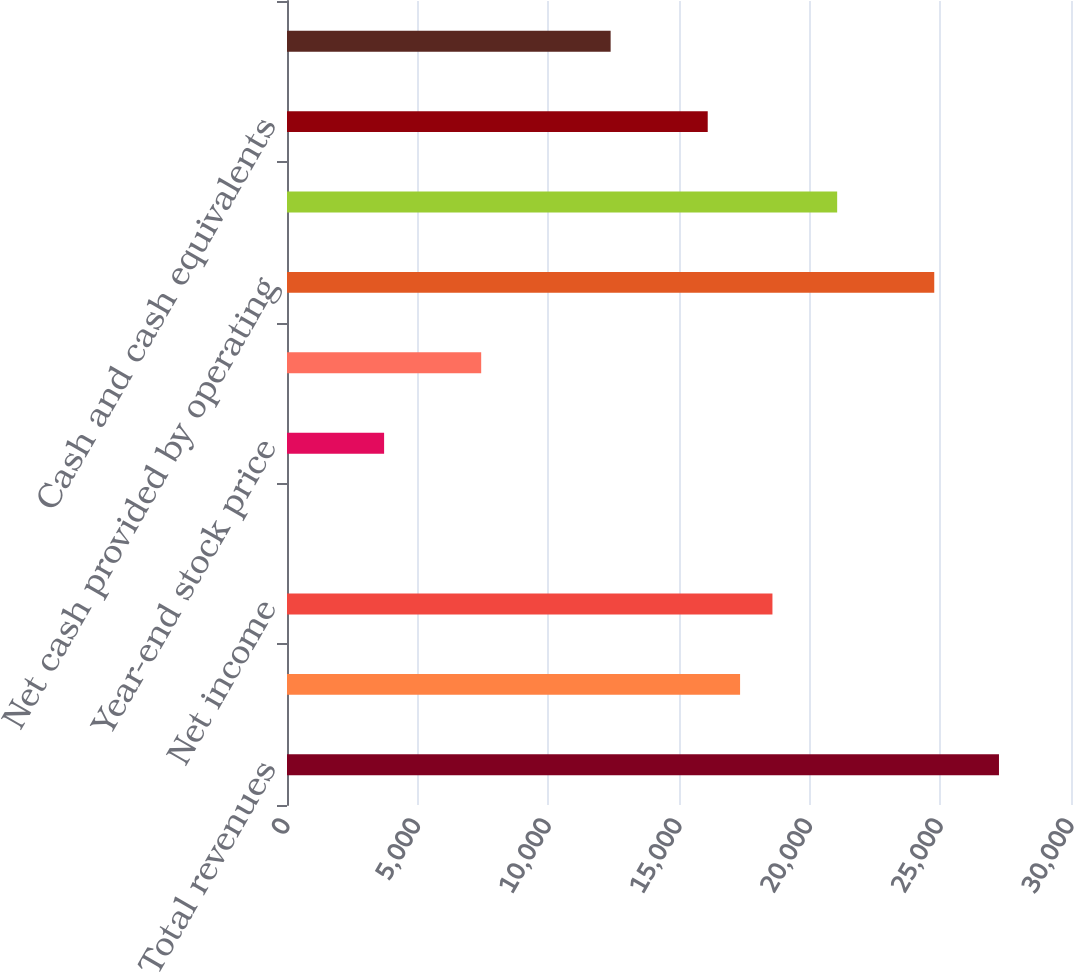Convert chart to OTSL. <chart><loc_0><loc_0><loc_500><loc_500><bar_chart><fcel>Total revenues<fcel>Income from continuing<fcel>Net income<fcel>Cash dividends<fcel>Year-end stock price<fcel>Basic weighted average shares<fcel>Net cash provided by operating<fcel>Additions to property plant<fcel>Cash and cash equivalents<fcel>Commodity derivative<nl><fcel>27243.9<fcel>17337.3<fcel>18575.6<fcel>0.66<fcel>3715.65<fcel>7430.64<fcel>24767.3<fcel>21052.3<fcel>16099<fcel>12384<nl></chart> 